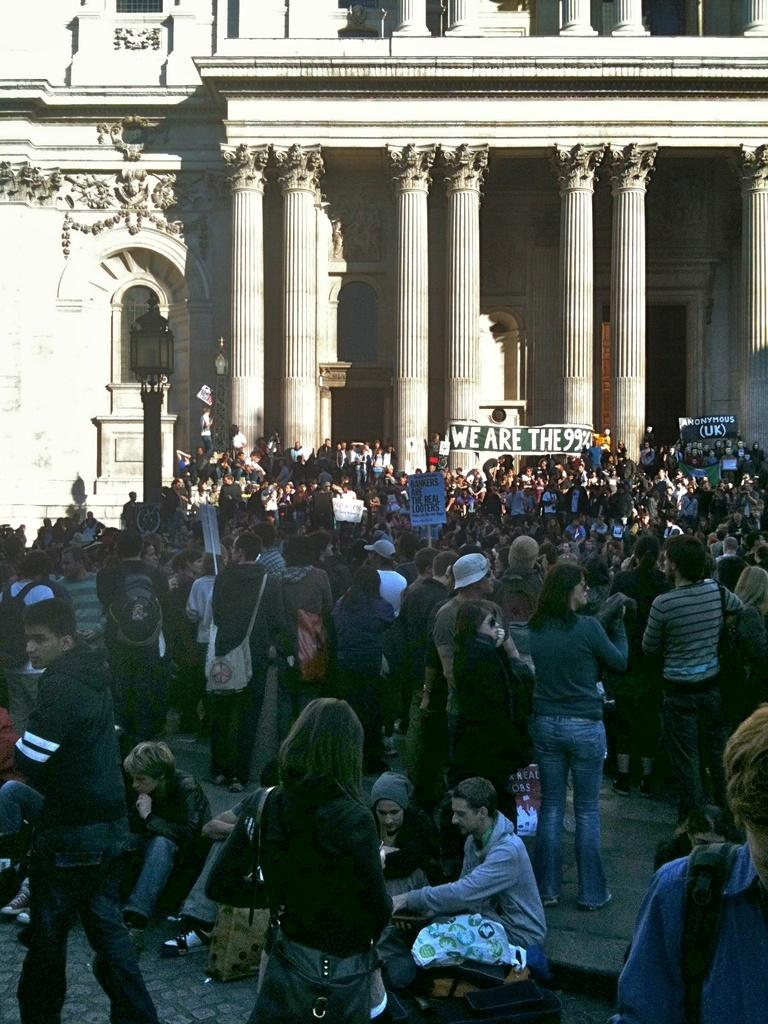Who is present in the image? There are people in the image. What type of building is in the background of the image? The people are standing in front of a legislative building. What are the people in the image doing? The people are protesting. What are the protesters holding in the image? The protesters are holding placards and banners. What type of drug is being sold by the protesters in the image? There is no indication in the image that the protesters are selling any drugs. What type of toy is being used by the protesters in the image? There is no toy present in the image; the protesters are holding placards and banners. 